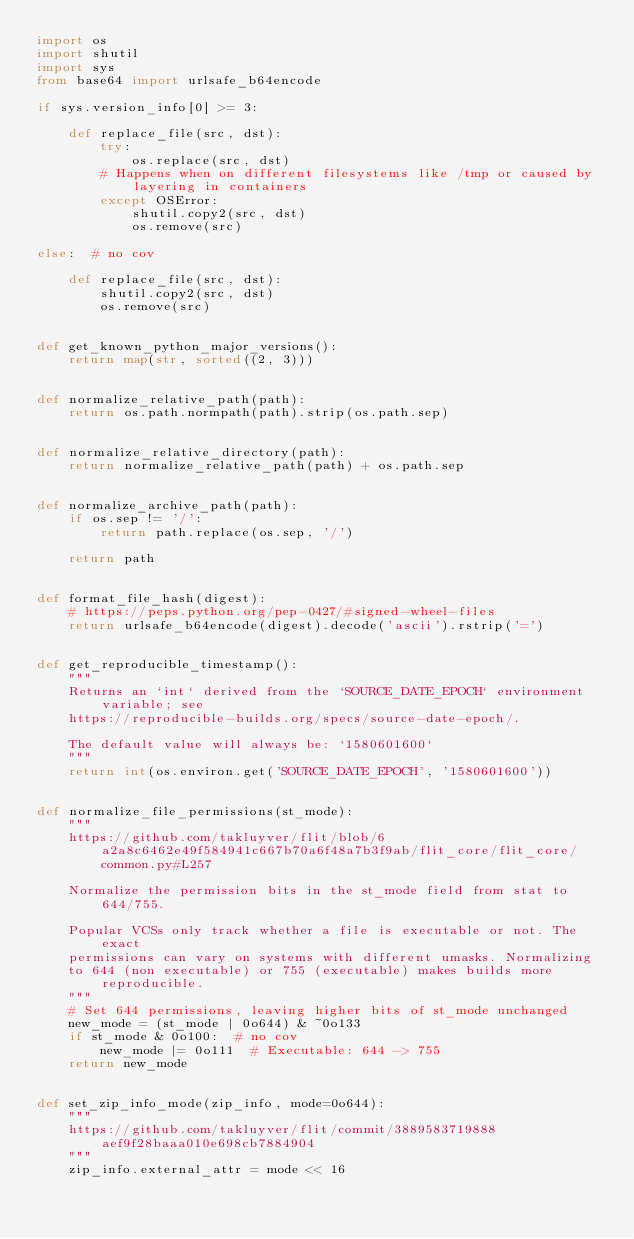Convert code to text. <code><loc_0><loc_0><loc_500><loc_500><_Python_>import os
import shutil
import sys
from base64 import urlsafe_b64encode

if sys.version_info[0] >= 3:

    def replace_file(src, dst):
        try:
            os.replace(src, dst)
        # Happens when on different filesystems like /tmp or caused by layering in containers
        except OSError:
            shutil.copy2(src, dst)
            os.remove(src)

else:  # no cov

    def replace_file(src, dst):
        shutil.copy2(src, dst)
        os.remove(src)


def get_known_python_major_versions():
    return map(str, sorted((2, 3)))


def normalize_relative_path(path):
    return os.path.normpath(path).strip(os.path.sep)


def normalize_relative_directory(path):
    return normalize_relative_path(path) + os.path.sep


def normalize_archive_path(path):
    if os.sep != '/':
        return path.replace(os.sep, '/')

    return path


def format_file_hash(digest):
    # https://peps.python.org/pep-0427/#signed-wheel-files
    return urlsafe_b64encode(digest).decode('ascii').rstrip('=')


def get_reproducible_timestamp():
    """
    Returns an `int` derived from the `SOURCE_DATE_EPOCH` environment variable; see
    https://reproducible-builds.org/specs/source-date-epoch/.

    The default value will always be: `1580601600`
    """
    return int(os.environ.get('SOURCE_DATE_EPOCH', '1580601600'))


def normalize_file_permissions(st_mode):
    """
    https://github.com/takluyver/flit/blob/6a2a8c6462e49f584941c667b70a6f48a7b3f9ab/flit_core/flit_core/common.py#L257

    Normalize the permission bits in the st_mode field from stat to 644/755.

    Popular VCSs only track whether a file is executable or not. The exact
    permissions can vary on systems with different umasks. Normalizing
    to 644 (non executable) or 755 (executable) makes builds more reproducible.
    """
    # Set 644 permissions, leaving higher bits of st_mode unchanged
    new_mode = (st_mode | 0o644) & ~0o133
    if st_mode & 0o100:  # no cov
        new_mode |= 0o111  # Executable: 644 -> 755
    return new_mode


def set_zip_info_mode(zip_info, mode=0o644):
    """
    https://github.com/takluyver/flit/commit/3889583719888aef9f28baaa010e698cb7884904
    """
    zip_info.external_attr = mode << 16
</code> 